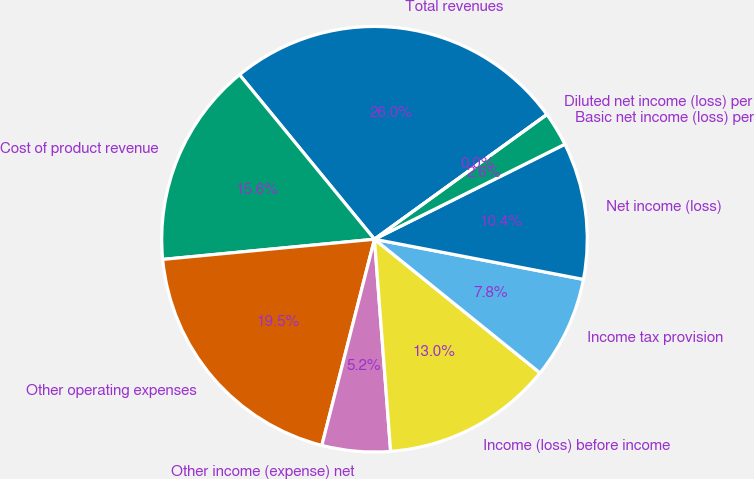<chart> <loc_0><loc_0><loc_500><loc_500><pie_chart><fcel>Total revenues<fcel>Cost of product revenue<fcel>Other operating expenses<fcel>Other income (expense) net<fcel>Income (loss) before income<fcel>Income tax provision<fcel>Net income (loss)<fcel>Basic net income (loss) per<fcel>Diluted net income (loss) per<nl><fcel>25.97%<fcel>15.58%<fcel>19.51%<fcel>5.19%<fcel>12.98%<fcel>7.79%<fcel>10.39%<fcel>2.6%<fcel>0.0%<nl></chart> 